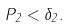Convert formula to latex. <formula><loc_0><loc_0><loc_500><loc_500>P _ { 2 } < \delta _ { 2 } .</formula> 